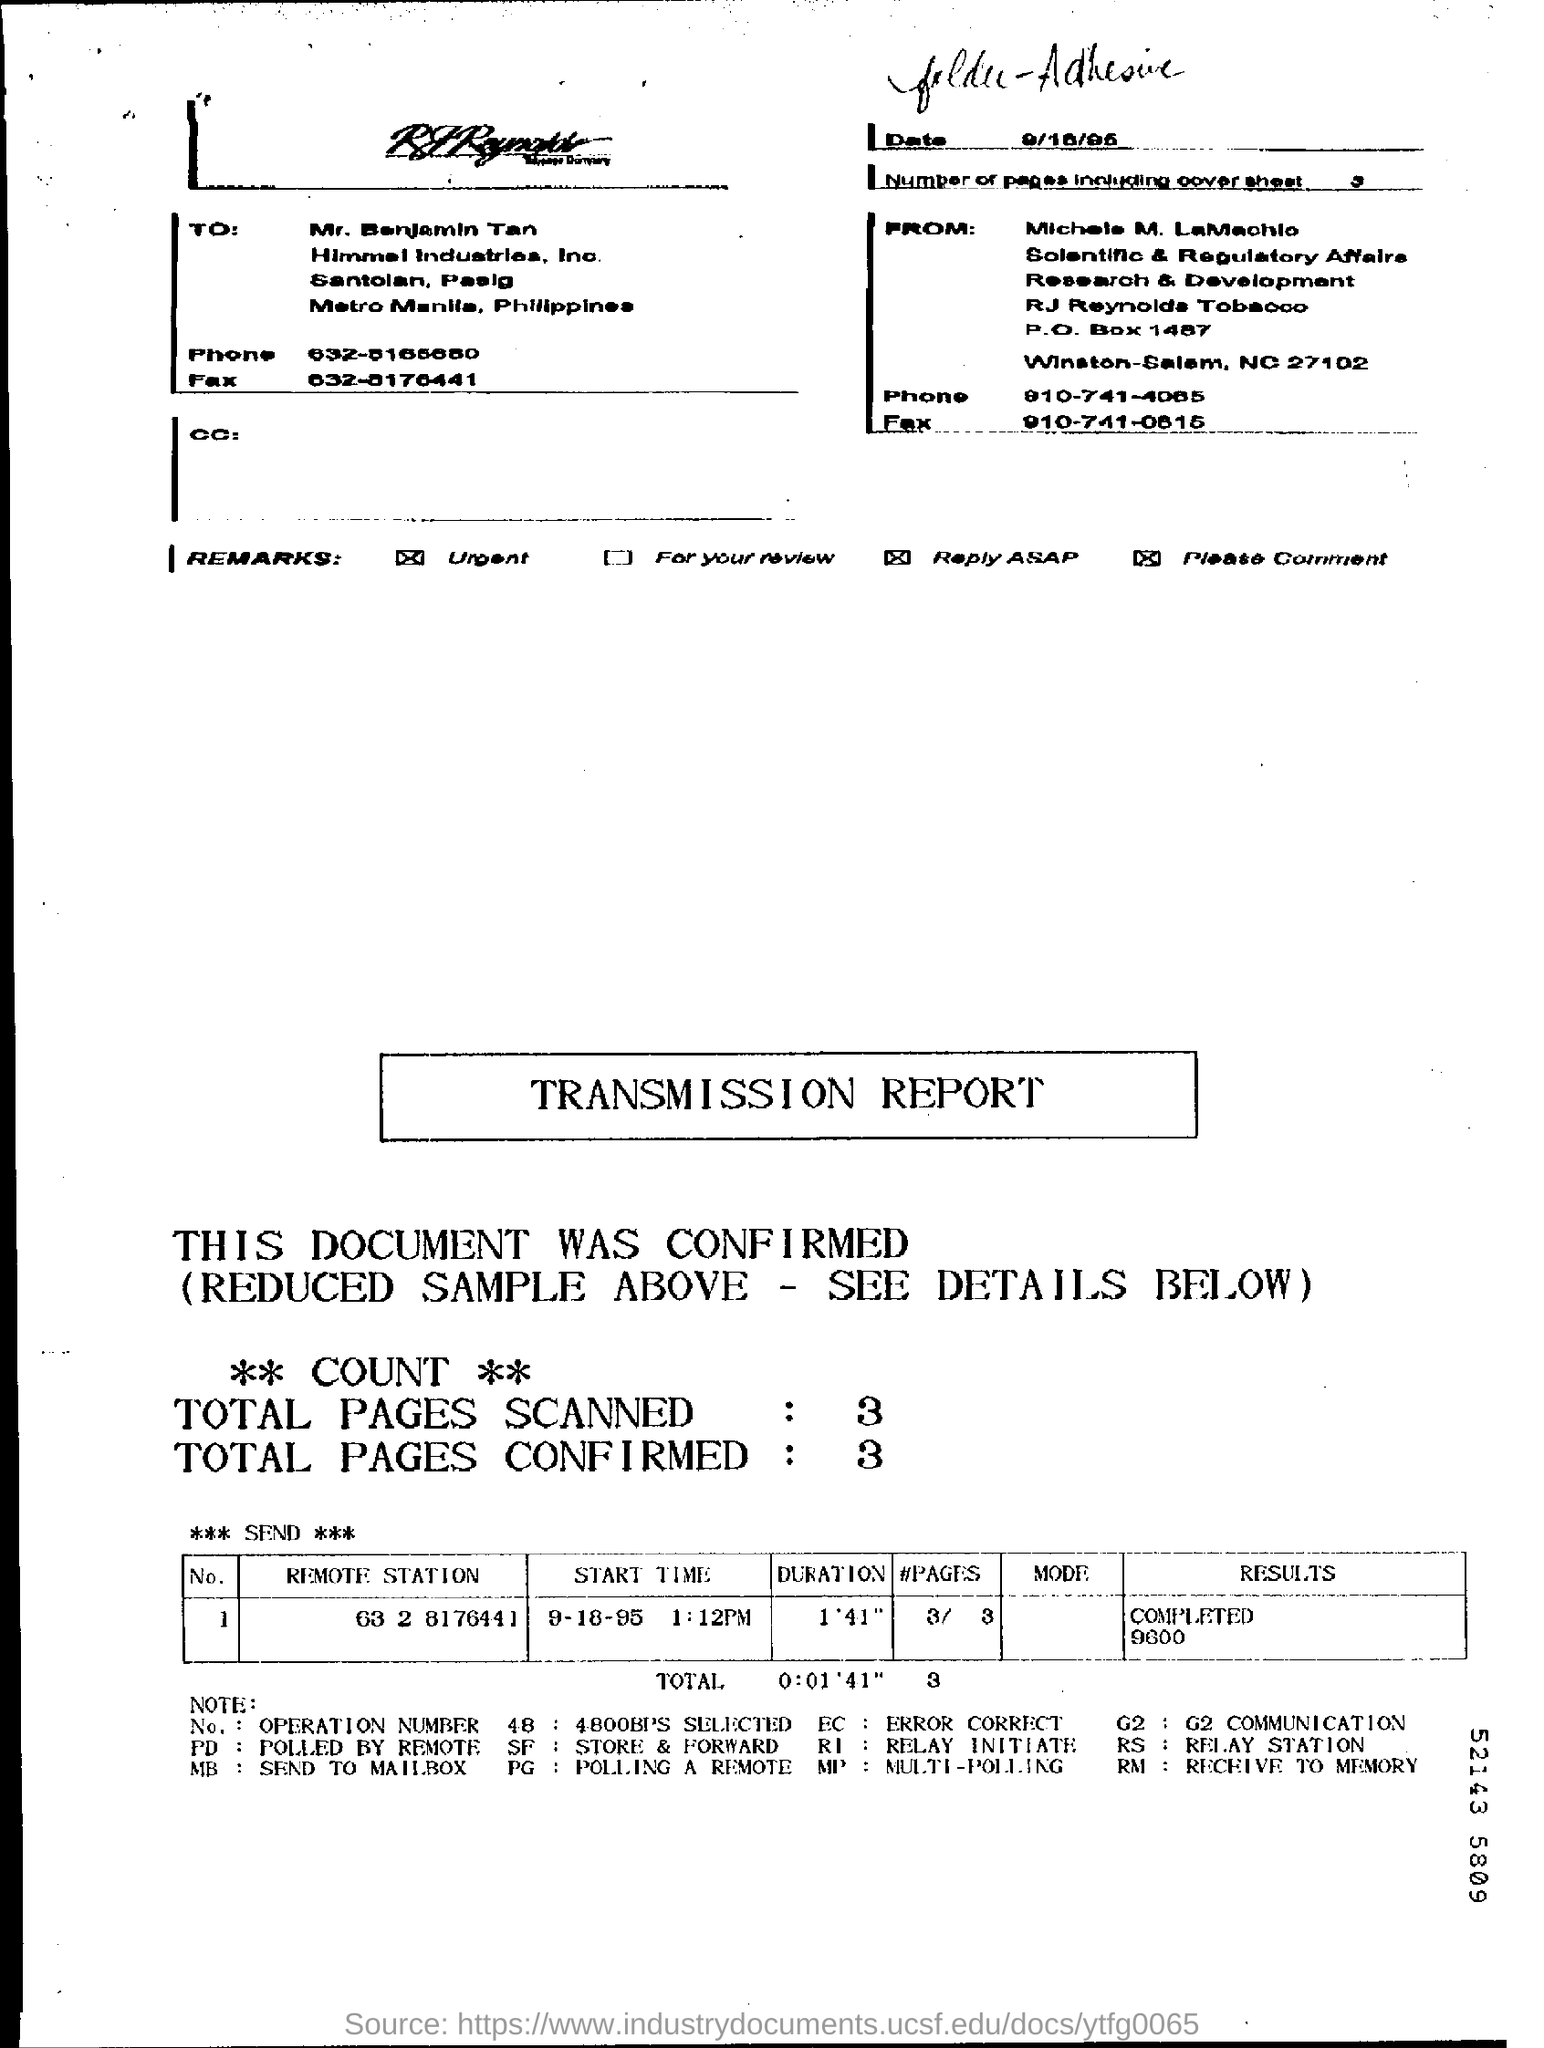Specify some key components in this picture. The document is addressed to Mr. Benjamin Tan. What is the total number of confirmed pages? 